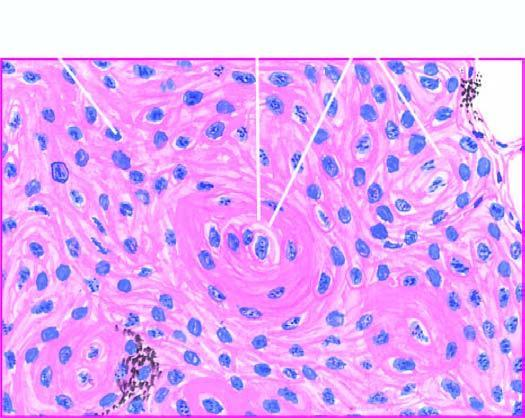re these tumour cells evident?
Answer the question using a single word or phrase. No 